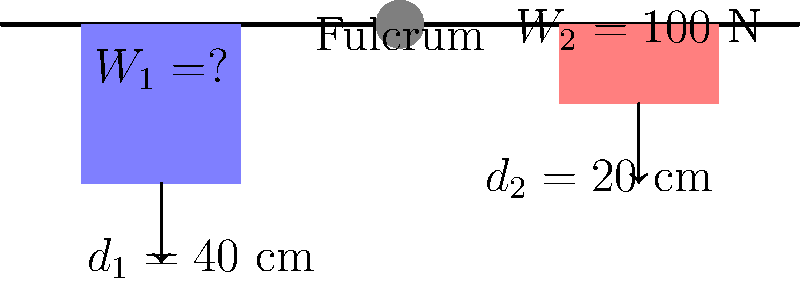As a local journalist investigating the history of simple machines in Tewksbury's industrial past, you come across a diagram of a lever system used in an old textile mill. The lever has a fulcrum in the center, with two weights on either side. If the weight on the right ($W_2$) is 100 N and is placed 20 cm from the fulcrum, while the unknown weight on the left ($W_1$) is placed 40 cm from the fulcrum, what should $W_1$ be for the lever to be in equilibrium? To solve this problem, we'll use the principle of moments for a lever in equilibrium. Here's a step-by-step explanation:

1) For a lever to be in equilibrium, the sum of moments about the fulcrum must be zero.

2) The moment of a force is calculated by multiplying the force by its perpendicular distance from the fulcrum.

3) Let's define clockwise moments as positive and counterclockwise moments as negative.

4) We can write the equation for the sum of moments:

   $$(W_1 \times d_1) - (W_2 \times d_2) = 0$$

5) Substituting the known values:

   $$(W_1 \times 40) - (100 \times 20) = 0$$

6) Simplify:

   $$40W_1 - 2000 = 0$$

7) Add 2000 to both sides:

   $$40W_1 = 2000$$

8) Divide both sides by 40:

   $$W_1 = \frac{2000}{40} = 50$$

Therefore, $W_1$ should be 50 N for the lever to be in equilibrium.
Answer: 50 N 